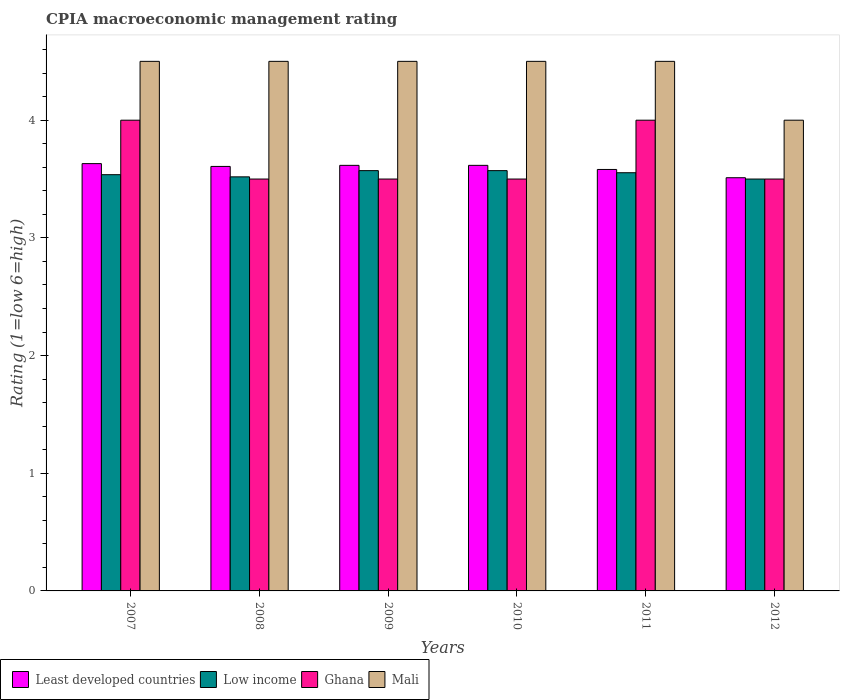How many groups of bars are there?
Keep it short and to the point. 6. How many bars are there on the 6th tick from the left?
Your answer should be very brief. 4. What is the label of the 5th group of bars from the left?
Provide a succinct answer. 2011. What is the CPIA rating in Low income in 2012?
Ensure brevity in your answer.  3.5. Across all years, what is the maximum CPIA rating in Ghana?
Provide a short and direct response. 4. In which year was the CPIA rating in Low income minimum?
Give a very brief answer. 2012. What is the total CPIA rating in Least developed countries in the graph?
Provide a succinct answer. 21.56. What is the difference between the CPIA rating in Least developed countries in 2009 and the CPIA rating in Low income in 2012?
Your answer should be very brief. 0.12. What is the average CPIA rating in Low income per year?
Ensure brevity in your answer.  3.54. In the year 2008, what is the difference between the CPIA rating in Least developed countries and CPIA rating in Ghana?
Your response must be concise. 0.11. What is the ratio of the CPIA rating in Least developed countries in 2009 to that in 2012?
Your answer should be compact. 1.03. Is the difference between the CPIA rating in Least developed countries in 2007 and 2011 greater than the difference between the CPIA rating in Ghana in 2007 and 2011?
Your response must be concise. Yes. What is the difference between the highest and the lowest CPIA rating in Ghana?
Provide a short and direct response. 0.5. Is it the case that in every year, the sum of the CPIA rating in Low income and CPIA rating in Mali is greater than the sum of CPIA rating in Least developed countries and CPIA rating in Ghana?
Ensure brevity in your answer.  No. What does the 3rd bar from the left in 2012 represents?
Ensure brevity in your answer.  Ghana. What does the 3rd bar from the right in 2009 represents?
Your answer should be very brief. Low income. Does the graph contain any zero values?
Offer a terse response. No. Does the graph contain grids?
Offer a very short reply. No. Where does the legend appear in the graph?
Offer a very short reply. Bottom left. How many legend labels are there?
Your response must be concise. 4. How are the legend labels stacked?
Keep it short and to the point. Horizontal. What is the title of the graph?
Your answer should be compact. CPIA macroeconomic management rating. Does "Niger" appear as one of the legend labels in the graph?
Make the answer very short. No. What is the label or title of the X-axis?
Offer a very short reply. Years. What is the Rating (1=low 6=high) of Least developed countries in 2007?
Offer a terse response. 3.63. What is the Rating (1=low 6=high) in Low income in 2007?
Provide a short and direct response. 3.54. What is the Rating (1=low 6=high) of Ghana in 2007?
Your answer should be very brief. 4. What is the Rating (1=low 6=high) in Least developed countries in 2008?
Make the answer very short. 3.61. What is the Rating (1=low 6=high) of Low income in 2008?
Keep it short and to the point. 3.52. What is the Rating (1=low 6=high) of Ghana in 2008?
Provide a short and direct response. 3.5. What is the Rating (1=low 6=high) of Mali in 2008?
Provide a short and direct response. 4.5. What is the Rating (1=low 6=high) of Least developed countries in 2009?
Offer a very short reply. 3.62. What is the Rating (1=low 6=high) in Low income in 2009?
Make the answer very short. 3.57. What is the Rating (1=low 6=high) in Ghana in 2009?
Give a very brief answer. 3.5. What is the Rating (1=low 6=high) of Mali in 2009?
Provide a short and direct response. 4.5. What is the Rating (1=low 6=high) of Least developed countries in 2010?
Your answer should be compact. 3.62. What is the Rating (1=low 6=high) of Low income in 2010?
Your answer should be compact. 3.57. What is the Rating (1=low 6=high) in Mali in 2010?
Make the answer very short. 4.5. What is the Rating (1=low 6=high) in Least developed countries in 2011?
Your answer should be very brief. 3.58. What is the Rating (1=low 6=high) in Low income in 2011?
Your answer should be very brief. 3.55. What is the Rating (1=low 6=high) of Mali in 2011?
Give a very brief answer. 4.5. What is the Rating (1=low 6=high) of Least developed countries in 2012?
Provide a succinct answer. 3.51. What is the Rating (1=low 6=high) in Low income in 2012?
Your response must be concise. 3.5. What is the Rating (1=low 6=high) of Ghana in 2012?
Provide a succinct answer. 3.5. What is the Rating (1=low 6=high) of Mali in 2012?
Provide a short and direct response. 4. Across all years, what is the maximum Rating (1=low 6=high) in Least developed countries?
Your answer should be very brief. 3.63. Across all years, what is the maximum Rating (1=low 6=high) in Low income?
Your answer should be compact. 3.57. Across all years, what is the maximum Rating (1=low 6=high) in Ghana?
Give a very brief answer. 4. Across all years, what is the maximum Rating (1=low 6=high) of Mali?
Your answer should be very brief. 4.5. Across all years, what is the minimum Rating (1=low 6=high) of Least developed countries?
Your answer should be compact. 3.51. What is the total Rating (1=low 6=high) in Least developed countries in the graph?
Ensure brevity in your answer.  21.56. What is the total Rating (1=low 6=high) in Low income in the graph?
Keep it short and to the point. 21.25. What is the total Rating (1=low 6=high) in Ghana in the graph?
Provide a short and direct response. 22. What is the difference between the Rating (1=low 6=high) in Least developed countries in 2007 and that in 2008?
Provide a succinct answer. 0.02. What is the difference between the Rating (1=low 6=high) of Low income in 2007 and that in 2008?
Offer a very short reply. 0.02. What is the difference between the Rating (1=low 6=high) of Ghana in 2007 and that in 2008?
Offer a terse response. 0.5. What is the difference between the Rating (1=low 6=high) of Least developed countries in 2007 and that in 2009?
Give a very brief answer. 0.01. What is the difference between the Rating (1=low 6=high) of Low income in 2007 and that in 2009?
Your answer should be very brief. -0.03. What is the difference between the Rating (1=low 6=high) in Ghana in 2007 and that in 2009?
Offer a terse response. 0.5. What is the difference between the Rating (1=low 6=high) in Mali in 2007 and that in 2009?
Your response must be concise. 0. What is the difference between the Rating (1=low 6=high) of Least developed countries in 2007 and that in 2010?
Your answer should be compact. 0.01. What is the difference between the Rating (1=low 6=high) in Low income in 2007 and that in 2010?
Ensure brevity in your answer.  -0.03. What is the difference between the Rating (1=low 6=high) of Ghana in 2007 and that in 2010?
Make the answer very short. 0.5. What is the difference between the Rating (1=low 6=high) in Mali in 2007 and that in 2010?
Your answer should be compact. 0. What is the difference between the Rating (1=low 6=high) in Least developed countries in 2007 and that in 2011?
Your answer should be very brief. 0.05. What is the difference between the Rating (1=low 6=high) in Low income in 2007 and that in 2011?
Provide a short and direct response. -0.02. What is the difference between the Rating (1=low 6=high) in Least developed countries in 2007 and that in 2012?
Your answer should be compact. 0.12. What is the difference between the Rating (1=low 6=high) of Low income in 2007 and that in 2012?
Your response must be concise. 0.04. What is the difference between the Rating (1=low 6=high) in Ghana in 2007 and that in 2012?
Provide a succinct answer. 0.5. What is the difference between the Rating (1=low 6=high) in Mali in 2007 and that in 2012?
Provide a short and direct response. 0.5. What is the difference between the Rating (1=low 6=high) of Least developed countries in 2008 and that in 2009?
Ensure brevity in your answer.  -0.01. What is the difference between the Rating (1=low 6=high) in Low income in 2008 and that in 2009?
Your response must be concise. -0.05. What is the difference between the Rating (1=low 6=high) of Ghana in 2008 and that in 2009?
Your answer should be compact. 0. What is the difference between the Rating (1=low 6=high) of Mali in 2008 and that in 2009?
Offer a very short reply. 0. What is the difference between the Rating (1=low 6=high) in Least developed countries in 2008 and that in 2010?
Ensure brevity in your answer.  -0.01. What is the difference between the Rating (1=low 6=high) in Low income in 2008 and that in 2010?
Your answer should be compact. -0.05. What is the difference between the Rating (1=low 6=high) in Least developed countries in 2008 and that in 2011?
Offer a terse response. 0.03. What is the difference between the Rating (1=low 6=high) of Low income in 2008 and that in 2011?
Offer a very short reply. -0.04. What is the difference between the Rating (1=low 6=high) of Ghana in 2008 and that in 2011?
Make the answer very short. -0.5. What is the difference between the Rating (1=low 6=high) of Least developed countries in 2008 and that in 2012?
Give a very brief answer. 0.1. What is the difference between the Rating (1=low 6=high) in Low income in 2008 and that in 2012?
Offer a very short reply. 0.02. What is the difference between the Rating (1=low 6=high) of Low income in 2009 and that in 2010?
Your answer should be very brief. 0. What is the difference between the Rating (1=low 6=high) in Ghana in 2009 and that in 2010?
Your response must be concise. 0. What is the difference between the Rating (1=low 6=high) in Least developed countries in 2009 and that in 2011?
Your answer should be compact. 0.03. What is the difference between the Rating (1=low 6=high) in Low income in 2009 and that in 2011?
Provide a short and direct response. 0.02. What is the difference between the Rating (1=low 6=high) in Ghana in 2009 and that in 2011?
Provide a succinct answer. -0.5. What is the difference between the Rating (1=low 6=high) of Least developed countries in 2009 and that in 2012?
Offer a very short reply. 0.11. What is the difference between the Rating (1=low 6=high) in Low income in 2009 and that in 2012?
Your answer should be compact. 0.07. What is the difference between the Rating (1=low 6=high) of Ghana in 2009 and that in 2012?
Offer a very short reply. 0. What is the difference between the Rating (1=low 6=high) of Least developed countries in 2010 and that in 2011?
Your answer should be very brief. 0.03. What is the difference between the Rating (1=low 6=high) in Low income in 2010 and that in 2011?
Offer a very short reply. 0.02. What is the difference between the Rating (1=low 6=high) of Ghana in 2010 and that in 2011?
Give a very brief answer. -0.5. What is the difference between the Rating (1=low 6=high) of Mali in 2010 and that in 2011?
Offer a very short reply. 0. What is the difference between the Rating (1=low 6=high) in Least developed countries in 2010 and that in 2012?
Offer a very short reply. 0.11. What is the difference between the Rating (1=low 6=high) in Low income in 2010 and that in 2012?
Ensure brevity in your answer.  0.07. What is the difference between the Rating (1=low 6=high) in Least developed countries in 2011 and that in 2012?
Offer a terse response. 0.07. What is the difference between the Rating (1=low 6=high) in Low income in 2011 and that in 2012?
Make the answer very short. 0.05. What is the difference between the Rating (1=low 6=high) in Mali in 2011 and that in 2012?
Keep it short and to the point. 0.5. What is the difference between the Rating (1=low 6=high) in Least developed countries in 2007 and the Rating (1=low 6=high) in Low income in 2008?
Give a very brief answer. 0.11. What is the difference between the Rating (1=low 6=high) of Least developed countries in 2007 and the Rating (1=low 6=high) of Ghana in 2008?
Keep it short and to the point. 0.13. What is the difference between the Rating (1=low 6=high) of Least developed countries in 2007 and the Rating (1=low 6=high) of Mali in 2008?
Your answer should be very brief. -0.87. What is the difference between the Rating (1=low 6=high) of Low income in 2007 and the Rating (1=low 6=high) of Ghana in 2008?
Ensure brevity in your answer.  0.04. What is the difference between the Rating (1=low 6=high) of Low income in 2007 and the Rating (1=low 6=high) of Mali in 2008?
Your response must be concise. -0.96. What is the difference between the Rating (1=low 6=high) in Least developed countries in 2007 and the Rating (1=low 6=high) in Low income in 2009?
Your answer should be very brief. 0.06. What is the difference between the Rating (1=low 6=high) of Least developed countries in 2007 and the Rating (1=low 6=high) of Ghana in 2009?
Ensure brevity in your answer.  0.13. What is the difference between the Rating (1=low 6=high) of Least developed countries in 2007 and the Rating (1=low 6=high) of Mali in 2009?
Ensure brevity in your answer.  -0.87. What is the difference between the Rating (1=low 6=high) of Low income in 2007 and the Rating (1=low 6=high) of Ghana in 2009?
Your response must be concise. 0.04. What is the difference between the Rating (1=low 6=high) of Low income in 2007 and the Rating (1=low 6=high) of Mali in 2009?
Your answer should be compact. -0.96. What is the difference between the Rating (1=low 6=high) of Ghana in 2007 and the Rating (1=low 6=high) of Mali in 2009?
Provide a short and direct response. -0.5. What is the difference between the Rating (1=low 6=high) in Least developed countries in 2007 and the Rating (1=low 6=high) in Low income in 2010?
Provide a short and direct response. 0.06. What is the difference between the Rating (1=low 6=high) in Least developed countries in 2007 and the Rating (1=low 6=high) in Ghana in 2010?
Keep it short and to the point. 0.13. What is the difference between the Rating (1=low 6=high) of Least developed countries in 2007 and the Rating (1=low 6=high) of Mali in 2010?
Give a very brief answer. -0.87. What is the difference between the Rating (1=low 6=high) of Low income in 2007 and the Rating (1=low 6=high) of Ghana in 2010?
Your answer should be very brief. 0.04. What is the difference between the Rating (1=low 6=high) of Low income in 2007 and the Rating (1=low 6=high) of Mali in 2010?
Provide a succinct answer. -0.96. What is the difference between the Rating (1=low 6=high) of Least developed countries in 2007 and the Rating (1=low 6=high) of Low income in 2011?
Keep it short and to the point. 0.08. What is the difference between the Rating (1=low 6=high) in Least developed countries in 2007 and the Rating (1=low 6=high) in Ghana in 2011?
Ensure brevity in your answer.  -0.37. What is the difference between the Rating (1=low 6=high) of Least developed countries in 2007 and the Rating (1=low 6=high) of Mali in 2011?
Offer a very short reply. -0.87. What is the difference between the Rating (1=low 6=high) in Low income in 2007 and the Rating (1=low 6=high) in Ghana in 2011?
Make the answer very short. -0.46. What is the difference between the Rating (1=low 6=high) of Low income in 2007 and the Rating (1=low 6=high) of Mali in 2011?
Your answer should be compact. -0.96. What is the difference between the Rating (1=low 6=high) in Ghana in 2007 and the Rating (1=low 6=high) in Mali in 2011?
Provide a short and direct response. -0.5. What is the difference between the Rating (1=low 6=high) of Least developed countries in 2007 and the Rating (1=low 6=high) of Low income in 2012?
Your answer should be very brief. 0.13. What is the difference between the Rating (1=low 6=high) of Least developed countries in 2007 and the Rating (1=low 6=high) of Ghana in 2012?
Offer a very short reply. 0.13. What is the difference between the Rating (1=low 6=high) in Least developed countries in 2007 and the Rating (1=low 6=high) in Mali in 2012?
Make the answer very short. -0.37. What is the difference between the Rating (1=low 6=high) of Low income in 2007 and the Rating (1=low 6=high) of Ghana in 2012?
Provide a succinct answer. 0.04. What is the difference between the Rating (1=low 6=high) of Low income in 2007 and the Rating (1=low 6=high) of Mali in 2012?
Your response must be concise. -0.46. What is the difference between the Rating (1=low 6=high) of Least developed countries in 2008 and the Rating (1=low 6=high) of Low income in 2009?
Give a very brief answer. 0.04. What is the difference between the Rating (1=low 6=high) of Least developed countries in 2008 and the Rating (1=low 6=high) of Ghana in 2009?
Offer a very short reply. 0.11. What is the difference between the Rating (1=low 6=high) in Least developed countries in 2008 and the Rating (1=low 6=high) in Mali in 2009?
Keep it short and to the point. -0.89. What is the difference between the Rating (1=low 6=high) of Low income in 2008 and the Rating (1=low 6=high) of Ghana in 2009?
Ensure brevity in your answer.  0.02. What is the difference between the Rating (1=low 6=high) of Low income in 2008 and the Rating (1=low 6=high) of Mali in 2009?
Offer a very short reply. -0.98. What is the difference between the Rating (1=low 6=high) in Least developed countries in 2008 and the Rating (1=low 6=high) in Low income in 2010?
Provide a succinct answer. 0.04. What is the difference between the Rating (1=low 6=high) in Least developed countries in 2008 and the Rating (1=low 6=high) in Ghana in 2010?
Ensure brevity in your answer.  0.11. What is the difference between the Rating (1=low 6=high) in Least developed countries in 2008 and the Rating (1=low 6=high) in Mali in 2010?
Your response must be concise. -0.89. What is the difference between the Rating (1=low 6=high) in Low income in 2008 and the Rating (1=low 6=high) in Ghana in 2010?
Ensure brevity in your answer.  0.02. What is the difference between the Rating (1=low 6=high) of Low income in 2008 and the Rating (1=low 6=high) of Mali in 2010?
Your answer should be very brief. -0.98. What is the difference between the Rating (1=low 6=high) in Ghana in 2008 and the Rating (1=low 6=high) in Mali in 2010?
Your response must be concise. -1. What is the difference between the Rating (1=low 6=high) of Least developed countries in 2008 and the Rating (1=low 6=high) of Low income in 2011?
Provide a succinct answer. 0.05. What is the difference between the Rating (1=low 6=high) of Least developed countries in 2008 and the Rating (1=low 6=high) of Ghana in 2011?
Offer a very short reply. -0.39. What is the difference between the Rating (1=low 6=high) in Least developed countries in 2008 and the Rating (1=low 6=high) in Mali in 2011?
Give a very brief answer. -0.89. What is the difference between the Rating (1=low 6=high) in Low income in 2008 and the Rating (1=low 6=high) in Ghana in 2011?
Offer a very short reply. -0.48. What is the difference between the Rating (1=low 6=high) of Low income in 2008 and the Rating (1=low 6=high) of Mali in 2011?
Your response must be concise. -0.98. What is the difference between the Rating (1=low 6=high) in Ghana in 2008 and the Rating (1=low 6=high) in Mali in 2011?
Offer a terse response. -1. What is the difference between the Rating (1=low 6=high) in Least developed countries in 2008 and the Rating (1=low 6=high) in Low income in 2012?
Provide a short and direct response. 0.11. What is the difference between the Rating (1=low 6=high) in Least developed countries in 2008 and the Rating (1=low 6=high) in Ghana in 2012?
Offer a terse response. 0.11. What is the difference between the Rating (1=low 6=high) of Least developed countries in 2008 and the Rating (1=low 6=high) of Mali in 2012?
Give a very brief answer. -0.39. What is the difference between the Rating (1=low 6=high) of Low income in 2008 and the Rating (1=low 6=high) of Ghana in 2012?
Make the answer very short. 0.02. What is the difference between the Rating (1=low 6=high) in Low income in 2008 and the Rating (1=low 6=high) in Mali in 2012?
Provide a succinct answer. -0.48. What is the difference between the Rating (1=low 6=high) in Least developed countries in 2009 and the Rating (1=low 6=high) in Low income in 2010?
Ensure brevity in your answer.  0.04. What is the difference between the Rating (1=low 6=high) in Least developed countries in 2009 and the Rating (1=low 6=high) in Ghana in 2010?
Offer a very short reply. 0.12. What is the difference between the Rating (1=low 6=high) of Least developed countries in 2009 and the Rating (1=low 6=high) of Mali in 2010?
Offer a very short reply. -0.88. What is the difference between the Rating (1=low 6=high) of Low income in 2009 and the Rating (1=low 6=high) of Ghana in 2010?
Keep it short and to the point. 0.07. What is the difference between the Rating (1=low 6=high) of Low income in 2009 and the Rating (1=low 6=high) of Mali in 2010?
Keep it short and to the point. -0.93. What is the difference between the Rating (1=low 6=high) in Ghana in 2009 and the Rating (1=low 6=high) in Mali in 2010?
Your answer should be very brief. -1. What is the difference between the Rating (1=low 6=high) in Least developed countries in 2009 and the Rating (1=low 6=high) in Low income in 2011?
Your response must be concise. 0.06. What is the difference between the Rating (1=low 6=high) in Least developed countries in 2009 and the Rating (1=low 6=high) in Ghana in 2011?
Offer a very short reply. -0.38. What is the difference between the Rating (1=low 6=high) in Least developed countries in 2009 and the Rating (1=low 6=high) in Mali in 2011?
Give a very brief answer. -0.88. What is the difference between the Rating (1=low 6=high) in Low income in 2009 and the Rating (1=low 6=high) in Ghana in 2011?
Provide a succinct answer. -0.43. What is the difference between the Rating (1=low 6=high) of Low income in 2009 and the Rating (1=low 6=high) of Mali in 2011?
Ensure brevity in your answer.  -0.93. What is the difference between the Rating (1=low 6=high) in Least developed countries in 2009 and the Rating (1=low 6=high) in Low income in 2012?
Offer a very short reply. 0.12. What is the difference between the Rating (1=low 6=high) of Least developed countries in 2009 and the Rating (1=low 6=high) of Ghana in 2012?
Offer a very short reply. 0.12. What is the difference between the Rating (1=low 6=high) in Least developed countries in 2009 and the Rating (1=low 6=high) in Mali in 2012?
Provide a succinct answer. -0.38. What is the difference between the Rating (1=low 6=high) of Low income in 2009 and the Rating (1=low 6=high) of Ghana in 2012?
Provide a succinct answer. 0.07. What is the difference between the Rating (1=low 6=high) in Low income in 2009 and the Rating (1=low 6=high) in Mali in 2012?
Your answer should be compact. -0.43. What is the difference between the Rating (1=low 6=high) in Least developed countries in 2010 and the Rating (1=low 6=high) in Low income in 2011?
Ensure brevity in your answer.  0.06. What is the difference between the Rating (1=low 6=high) of Least developed countries in 2010 and the Rating (1=low 6=high) of Ghana in 2011?
Provide a succinct answer. -0.38. What is the difference between the Rating (1=low 6=high) of Least developed countries in 2010 and the Rating (1=low 6=high) of Mali in 2011?
Your answer should be very brief. -0.88. What is the difference between the Rating (1=low 6=high) in Low income in 2010 and the Rating (1=low 6=high) in Ghana in 2011?
Provide a short and direct response. -0.43. What is the difference between the Rating (1=low 6=high) of Low income in 2010 and the Rating (1=low 6=high) of Mali in 2011?
Your answer should be compact. -0.93. What is the difference between the Rating (1=low 6=high) of Least developed countries in 2010 and the Rating (1=low 6=high) of Low income in 2012?
Give a very brief answer. 0.12. What is the difference between the Rating (1=low 6=high) of Least developed countries in 2010 and the Rating (1=low 6=high) of Ghana in 2012?
Give a very brief answer. 0.12. What is the difference between the Rating (1=low 6=high) of Least developed countries in 2010 and the Rating (1=low 6=high) of Mali in 2012?
Provide a short and direct response. -0.38. What is the difference between the Rating (1=low 6=high) in Low income in 2010 and the Rating (1=low 6=high) in Ghana in 2012?
Offer a terse response. 0.07. What is the difference between the Rating (1=low 6=high) in Low income in 2010 and the Rating (1=low 6=high) in Mali in 2012?
Your answer should be very brief. -0.43. What is the difference between the Rating (1=low 6=high) in Ghana in 2010 and the Rating (1=low 6=high) in Mali in 2012?
Your answer should be very brief. -0.5. What is the difference between the Rating (1=low 6=high) in Least developed countries in 2011 and the Rating (1=low 6=high) in Low income in 2012?
Your answer should be very brief. 0.08. What is the difference between the Rating (1=low 6=high) in Least developed countries in 2011 and the Rating (1=low 6=high) in Ghana in 2012?
Provide a succinct answer. 0.08. What is the difference between the Rating (1=low 6=high) in Least developed countries in 2011 and the Rating (1=low 6=high) in Mali in 2012?
Ensure brevity in your answer.  -0.42. What is the difference between the Rating (1=low 6=high) of Low income in 2011 and the Rating (1=low 6=high) of Ghana in 2012?
Your response must be concise. 0.05. What is the difference between the Rating (1=low 6=high) of Low income in 2011 and the Rating (1=low 6=high) of Mali in 2012?
Give a very brief answer. -0.45. What is the average Rating (1=low 6=high) in Least developed countries per year?
Your response must be concise. 3.59. What is the average Rating (1=low 6=high) of Low income per year?
Provide a succinct answer. 3.54. What is the average Rating (1=low 6=high) of Ghana per year?
Your answer should be compact. 3.67. What is the average Rating (1=low 6=high) of Mali per year?
Your answer should be very brief. 4.42. In the year 2007, what is the difference between the Rating (1=low 6=high) in Least developed countries and Rating (1=low 6=high) in Low income?
Your response must be concise. 0.09. In the year 2007, what is the difference between the Rating (1=low 6=high) of Least developed countries and Rating (1=low 6=high) of Ghana?
Ensure brevity in your answer.  -0.37. In the year 2007, what is the difference between the Rating (1=low 6=high) of Least developed countries and Rating (1=low 6=high) of Mali?
Provide a short and direct response. -0.87. In the year 2007, what is the difference between the Rating (1=low 6=high) in Low income and Rating (1=low 6=high) in Ghana?
Give a very brief answer. -0.46. In the year 2007, what is the difference between the Rating (1=low 6=high) of Low income and Rating (1=low 6=high) of Mali?
Your response must be concise. -0.96. In the year 2008, what is the difference between the Rating (1=low 6=high) of Least developed countries and Rating (1=low 6=high) of Low income?
Keep it short and to the point. 0.09. In the year 2008, what is the difference between the Rating (1=low 6=high) of Least developed countries and Rating (1=low 6=high) of Ghana?
Your answer should be very brief. 0.11. In the year 2008, what is the difference between the Rating (1=low 6=high) in Least developed countries and Rating (1=low 6=high) in Mali?
Your answer should be compact. -0.89. In the year 2008, what is the difference between the Rating (1=low 6=high) of Low income and Rating (1=low 6=high) of Ghana?
Offer a very short reply. 0.02. In the year 2008, what is the difference between the Rating (1=low 6=high) in Low income and Rating (1=low 6=high) in Mali?
Offer a very short reply. -0.98. In the year 2008, what is the difference between the Rating (1=low 6=high) of Ghana and Rating (1=low 6=high) of Mali?
Give a very brief answer. -1. In the year 2009, what is the difference between the Rating (1=low 6=high) in Least developed countries and Rating (1=low 6=high) in Low income?
Ensure brevity in your answer.  0.04. In the year 2009, what is the difference between the Rating (1=low 6=high) in Least developed countries and Rating (1=low 6=high) in Ghana?
Your response must be concise. 0.12. In the year 2009, what is the difference between the Rating (1=low 6=high) of Least developed countries and Rating (1=low 6=high) of Mali?
Give a very brief answer. -0.88. In the year 2009, what is the difference between the Rating (1=low 6=high) in Low income and Rating (1=low 6=high) in Ghana?
Your answer should be very brief. 0.07. In the year 2009, what is the difference between the Rating (1=low 6=high) of Low income and Rating (1=low 6=high) of Mali?
Keep it short and to the point. -0.93. In the year 2010, what is the difference between the Rating (1=low 6=high) of Least developed countries and Rating (1=low 6=high) of Low income?
Offer a terse response. 0.04. In the year 2010, what is the difference between the Rating (1=low 6=high) in Least developed countries and Rating (1=low 6=high) in Ghana?
Offer a very short reply. 0.12. In the year 2010, what is the difference between the Rating (1=low 6=high) in Least developed countries and Rating (1=low 6=high) in Mali?
Ensure brevity in your answer.  -0.88. In the year 2010, what is the difference between the Rating (1=low 6=high) of Low income and Rating (1=low 6=high) of Ghana?
Make the answer very short. 0.07. In the year 2010, what is the difference between the Rating (1=low 6=high) in Low income and Rating (1=low 6=high) in Mali?
Your response must be concise. -0.93. In the year 2010, what is the difference between the Rating (1=low 6=high) of Ghana and Rating (1=low 6=high) of Mali?
Your answer should be compact. -1. In the year 2011, what is the difference between the Rating (1=low 6=high) of Least developed countries and Rating (1=low 6=high) of Low income?
Make the answer very short. 0.03. In the year 2011, what is the difference between the Rating (1=low 6=high) in Least developed countries and Rating (1=low 6=high) in Ghana?
Your answer should be very brief. -0.42. In the year 2011, what is the difference between the Rating (1=low 6=high) in Least developed countries and Rating (1=low 6=high) in Mali?
Provide a short and direct response. -0.92. In the year 2011, what is the difference between the Rating (1=low 6=high) of Low income and Rating (1=low 6=high) of Ghana?
Make the answer very short. -0.45. In the year 2011, what is the difference between the Rating (1=low 6=high) of Low income and Rating (1=low 6=high) of Mali?
Keep it short and to the point. -0.95. In the year 2011, what is the difference between the Rating (1=low 6=high) of Ghana and Rating (1=low 6=high) of Mali?
Provide a short and direct response. -0.5. In the year 2012, what is the difference between the Rating (1=low 6=high) of Least developed countries and Rating (1=low 6=high) of Low income?
Provide a short and direct response. 0.01. In the year 2012, what is the difference between the Rating (1=low 6=high) of Least developed countries and Rating (1=low 6=high) of Ghana?
Your answer should be compact. 0.01. In the year 2012, what is the difference between the Rating (1=low 6=high) of Least developed countries and Rating (1=low 6=high) of Mali?
Ensure brevity in your answer.  -0.49. In the year 2012, what is the difference between the Rating (1=low 6=high) of Low income and Rating (1=low 6=high) of Ghana?
Give a very brief answer. 0. In the year 2012, what is the difference between the Rating (1=low 6=high) in Low income and Rating (1=low 6=high) in Mali?
Your answer should be compact. -0.5. What is the ratio of the Rating (1=low 6=high) in Least developed countries in 2007 to that in 2008?
Offer a terse response. 1.01. What is the ratio of the Rating (1=low 6=high) in Ghana in 2007 to that in 2008?
Provide a succinct answer. 1.14. What is the ratio of the Rating (1=low 6=high) in Least developed countries in 2007 to that in 2009?
Provide a short and direct response. 1. What is the ratio of the Rating (1=low 6=high) of Ghana in 2007 to that in 2009?
Ensure brevity in your answer.  1.14. What is the ratio of the Rating (1=low 6=high) of Mali in 2007 to that in 2009?
Give a very brief answer. 1. What is the ratio of the Rating (1=low 6=high) of Least developed countries in 2007 to that in 2010?
Offer a very short reply. 1. What is the ratio of the Rating (1=low 6=high) in Low income in 2007 to that in 2010?
Make the answer very short. 0.99. What is the ratio of the Rating (1=low 6=high) in Ghana in 2007 to that in 2010?
Provide a short and direct response. 1.14. What is the ratio of the Rating (1=low 6=high) of Mali in 2007 to that in 2010?
Offer a very short reply. 1. What is the ratio of the Rating (1=low 6=high) of Least developed countries in 2007 to that in 2011?
Provide a succinct answer. 1.01. What is the ratio of the Rating (1=low 6=high) in Least developed countries in 2007 to that in 2012?
Your answer should be compact. 1.03. What is the ratio of the Rating (1=low 6=high) in Low income in 2007 to that in 2012?
Your answer should be compact. 1.01. What is the ratio of the Rating (1=low 6=high) in Ghana in 2007 to that in 2012?
Ensure brevity in your answer.  1.14. What is the ratio of the Rating (1=low 6=high) of Least developed countries in 2008 to that in 2009?
Your answer should be very brief. 1. What is the ratio of the Rating (1=low 6=high) in Low income in 2008 to that in 2009?
Your answer should be very brief. 0.99. What is the ratio of the Rating (1=low 6=high) of Mali in 2008 to that in 2009?
Make the answer very short. 1. What is the ratio of the Rating (1=low 6=high) of Least developed countries in 2008 to that in 2010?
Your response must be concise. 1. What is the ratio of the Rating (1=low 6=high) in Low income in 2008 to that in 2010?
Offer a very short reply. 0.99. What is the ratio of the Rating (1=low 6=high) of Mali in 2008 to that in 2010?
Provide a short and direct response. 1. What is the ratio of the Rating (1=low 6=high) in Least developed countries in 2008 to that in 2011?
Make the answer very short. 1.01. What is the ratio of the Rating (1=low 6=high) in Low income in 2008 to that in 2011?
Provide a succinct answer. 0.99. What is the ratio of the Rating (1=low 6=high) in Least developed countries in 2008 to that in 2012?
Keep it short and to the point. 1.03. What is the ratio of the Rating (1=low 6=high) in Ghana in 2008 to that in 2012?
Offer a terse response. 1. What is the ratio of the Rating (1=low 6=high) in Mali in 2008 to that in 2012?
Provide a succinct answer. 1.12. What is the ratio of the Rating (1=low 6=high) of Least developed countries in 2009 to that in 2010?
Your answer should be very brief. 1. What is the ratio of the Rating (1=low 6=high) in Ghana in 2009 to that in 2010?
Make the answer very short. 1. What is the ratio of the Rating (1=low 6=high) in Least developed countries in 2009 to that in 2011?
Your answer should be compact. 1.01. What is the ratio of the Rating (1=low 6=high) in Low income in 2009 to that in 2011?
Offer a terse response. 1. What is the ratio of the Rating (1=low 6=high) in Ghana in 2009 to that in 2011?
Provide a succinct answer. 0.88. What is the ratio of the Rating (1=low 6=high) in Low income in 2009 to that in 2012?
Make the answer very short. 1.02. What is the ratio of the Rating (1=low 6=high) of Ghana in 2009 to that in 2012?
Give a very brief answer. 1. What is the ratio of the Rating (1=low 6=high) of Mali in 2009 to that in 2012?
Your response must be concise. 1.12. What is the ratio of the Rating (1=low 6=high) in Least developed countries in 2010 to that in 2011?
Ensure brevity in your answer.  1.01. What is the ratio of the Rating (1=low 6=high) of Ghana in 2010 to that in 2011?
Ensure brevity in your answer.  0.88. What is the ratio of the Rating (1=low 6=high) in Mali in 2010 to that in 2011?
Keep it short and to the point. 1. What is the ratio of the Rating (1=low 6=high) in Least developed countries in 2010 to that in 2012?
Give a very brief answer. 1.03. What is the ratio of the Rating (1=low 6=high) of Low income in 2010 to that in 2012?
Provide a short and direct response. 1.02. What is the ratio of the Rating (1=low 6=high) in Ghana in 2010 to that in 2012?
Provide a short and direct response. 1. What is the ratio of the Rating (1=low 6=high) in Least developed countries in 2011 to that in 2012?
Give a very brief answer. 1.02. What is the ratio of the Rating (1=low 6=high) of Low income in 2011 to that in 2012?
Provide a succinct answer. 1.02. What is the ratio of the Rating (1=low 6=high) of Ghana in 2011 to that in 2012?
Your answer should be very brief. 1.14. What is the difference between the highest and the second highest Rating (1=low 6=high) of Least developed countries?
Make the answer very short. 0.01. What is the difference between the highest and the second highest Rating (1=low 6=high) in Low income?
Give a very brief answer. 0. What is the difference between the highest and the second highest Rating (1=low 6=high) in Ghana?
Ensure brevity in your answer.  0. What is the difference between the highest and the lowest Rating (1=low 6=high) of Least developed countries?
Your answer should be compact. 0.12. What is the difference between the highest and the lowest Rating (1=low 6=high) of Low income?
Offer a very short reply. 0.07. What is the difference between the highest and the lowest Rating (1=low 6=high) in Mali?
Provide a succinct answer. 0.5. 